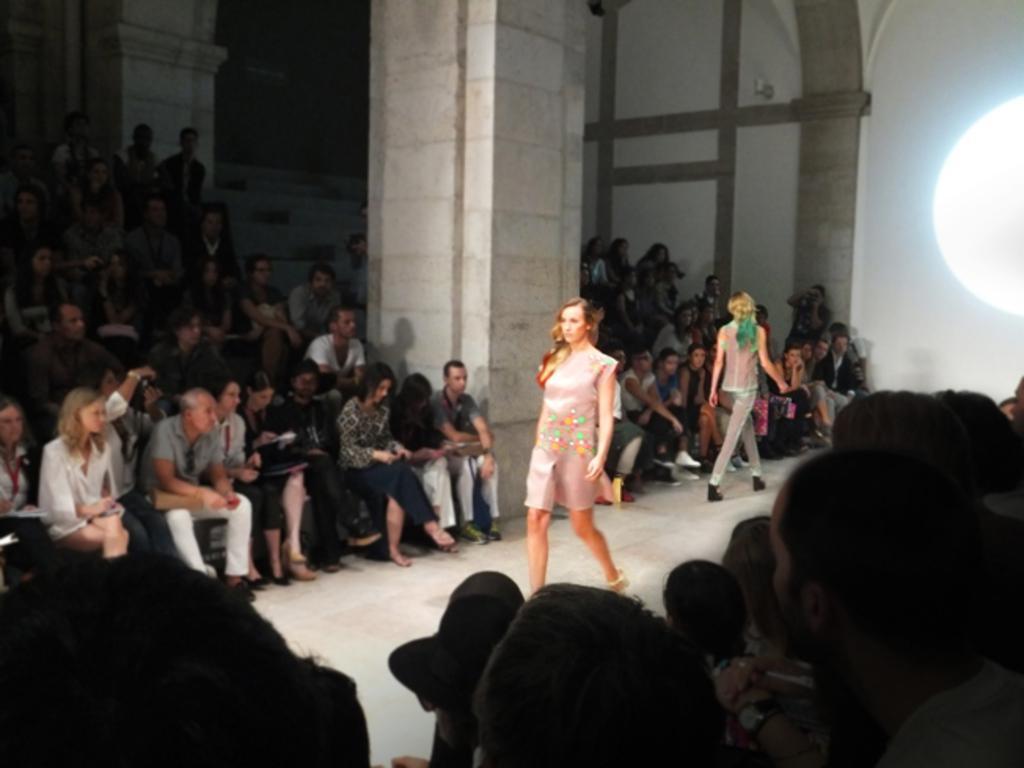Can you describe this image briefly? In this image we can see ladies walking. There is a ramp and we can see crowd sitting. There is a pillar. On the right we can see a light. In the background there is a wall. 